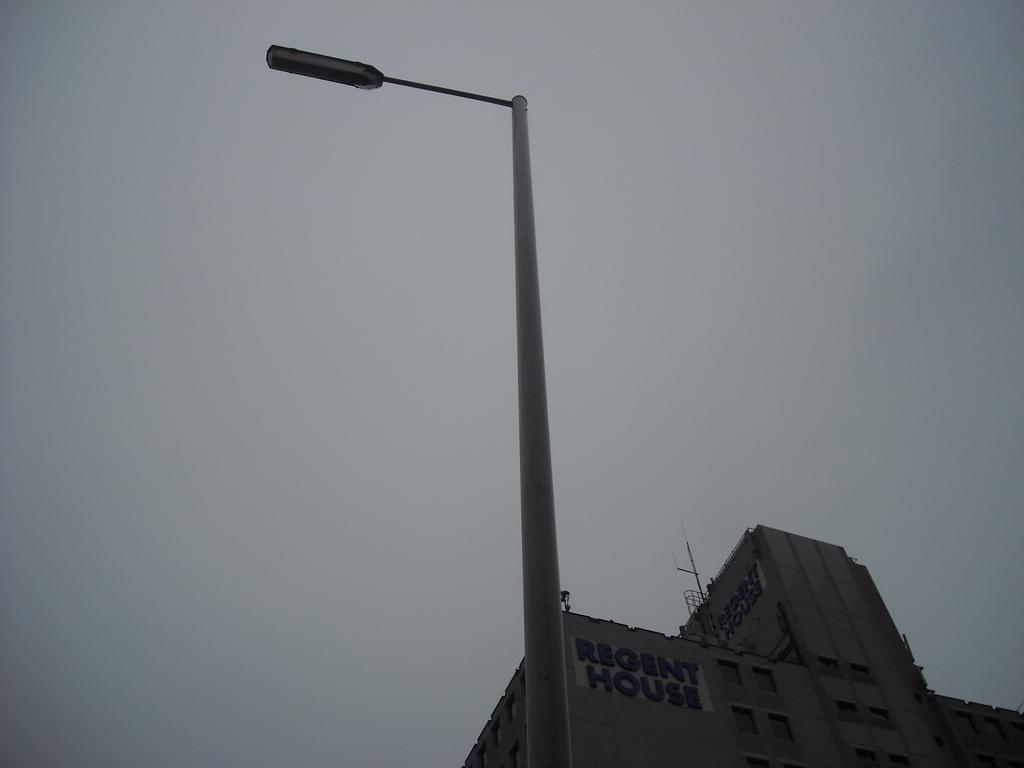What is the main object in the foreground of the image? There is a street light in the image. What structure is located behind the street light? There is a building behind the street light. What can be seen in the background of the image? The sky is visible in the background of the image. Where is the tray located in the image? There is no tray present in the image. What type of town is depicted in the image? The image does not depict a town; it features a street light, a building, and the sky. 